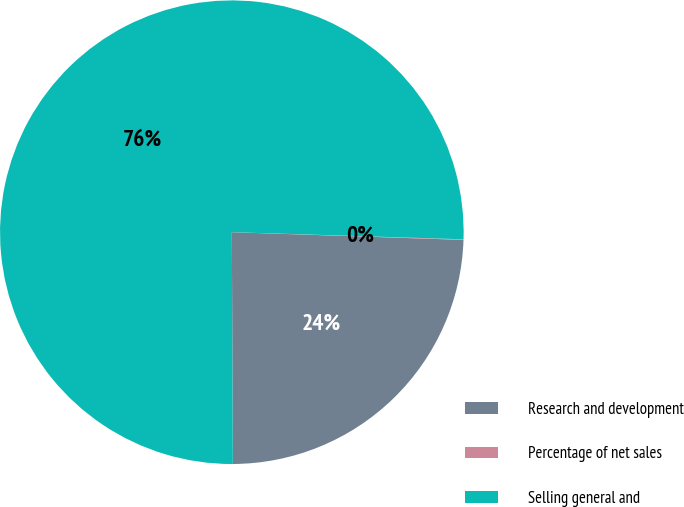Convert chart. <chart><loc_0><loc_0><loc_500><loc_500><pie_chart><fcel>Research and development<fcel>Percentage of net sales<fcel>Selling general and<nl><fcel>24.4%<fcel>0.04%<fcel>75.55%<nl></chart> 